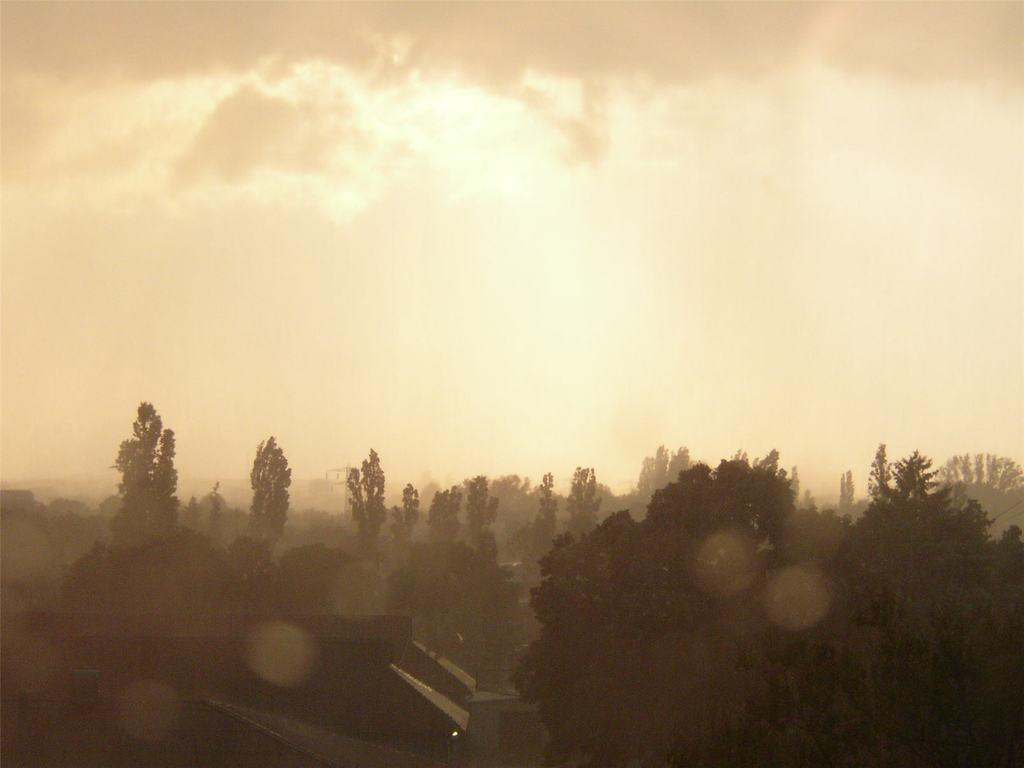What type of structure is present in the image? There is a building in the image. What other natural elements can be seen in the image? There are trees in the image. What part of the natural environment is visible in the image? The sky is visible in the image. How many ducks are visible in the image? There are no ducks present in the image. What type of fruit can be seen hanging from the trees in the image? There is no fruit visible in the image, as it only features a building, trees, and the sky. 